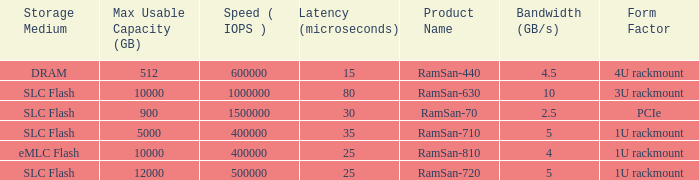List the range distroration for the ramsan-630 3U rackmount. 